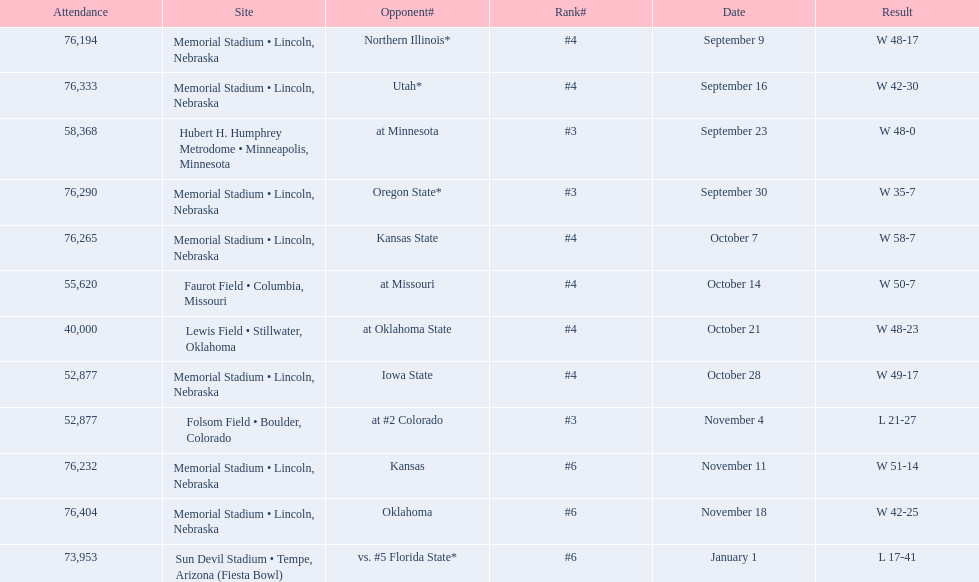Which opponenets did the nebraska cornhuskers score fewer than 40 points against? Oregon State*, at #2 Colorado, vs. #5 Florida State*. Of these games, which ones had an attendance of greater than 70,000? Oregon State*, vs. #5 Florida State*. Which of these opponents did they beat? Oregon State*. How many people were in attendance at that game? 76,290. 